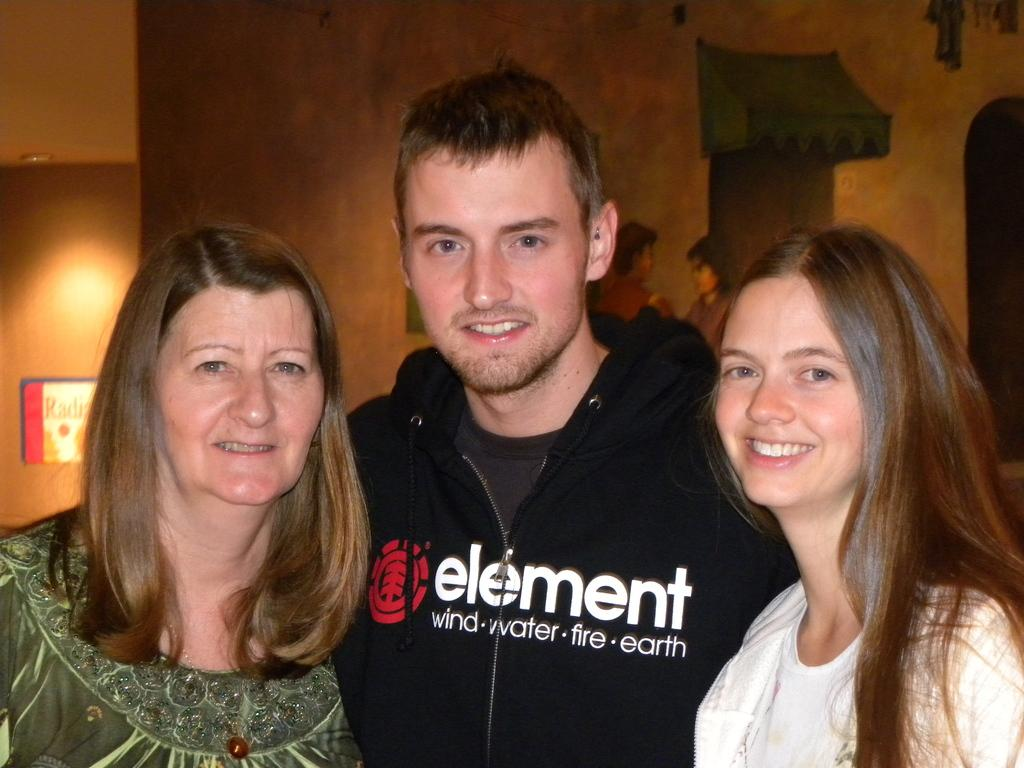How many people are present in the image? There is a man and two women in the image. What can be seen on the wall in the background? There is a painting on the wall in the background. What is on the wall on the left side? There is a board on the wall on the left side. What type of collar can be seen on the church in the image? There is no church present in the image, so there is no collar to be seen. 